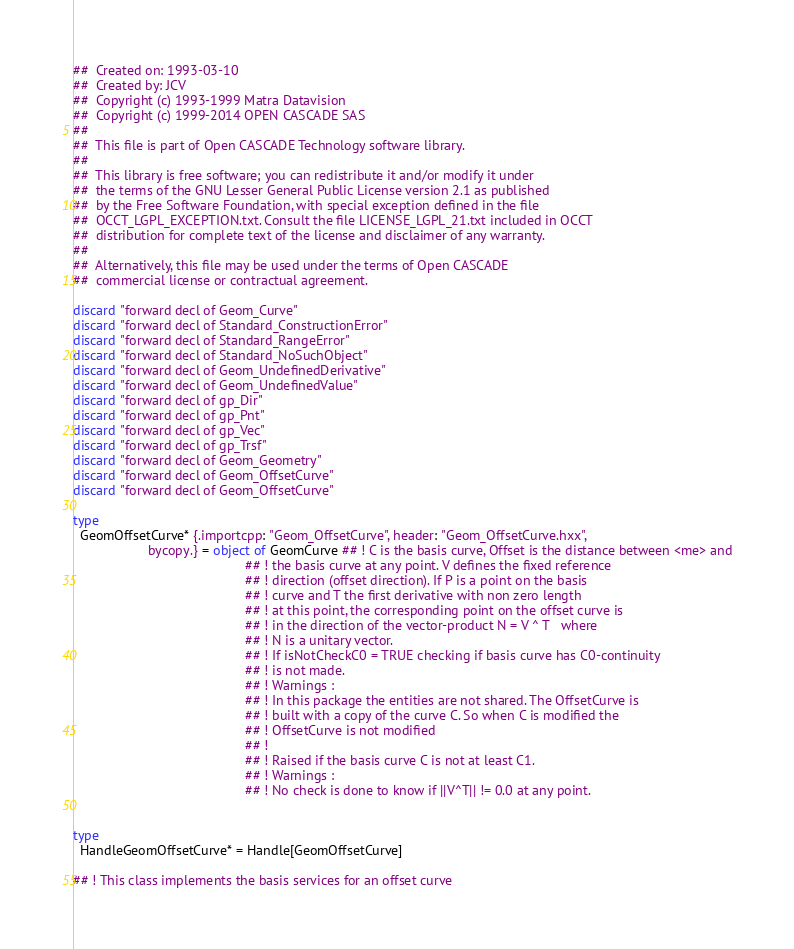<code> <loc_0><loc_0><loc_500><loc_500><_Nim_>##  Created on: 1993-03-10
##  Created by: JCV
##  Copyright (c) 1993-1999 Matra Datavision
##  Copyright (c) 1999-2014 OPEN CASCADE SAS
##
##  This file is part of Open CASCADE Technology software library.
##
##  This library is free software; you can redistribute it and/or modify it under
##  the terms of the GNU Lesser General Public License version 2.1 as published
##  by the Free Software Foundation, with special exception defined in the file
##  OCCT_LGPL_EXCEPTION.txt. Consult the file LICENSE_LGPL_21.txt included in OCCT
##  distribution for complete text of the license and disclaimer of any warranty.
##
##  Alternatively, this file may be used under the terms of Open CASCADE
##  commercial license or contractual agreement.

discard "forward decl of Geom_Curve"
discard "forward decl of Standard_ConstructionError"
discard "forward decl of Standard_RangeError"
discard "forward decl of Standard_NoSuchObject"
discard "forward decl of Geom_UndefinedDerivative"
discard "forward decl of Geom_UndefinedValue"
discard "forward decl of gp_Dir"
discard "forward decl of gp_Pnt"
discard "forward decl of gp_Vec"
discard "forward decl of gp_Trsf"
discard "forward decl of Geom_Geometry"
discard "forward decl of Geom_OffsetCurve"
discard "forward decl of Geom_OffsetCurve"

type
  GeomOffsetCurve* {.importcpp: "Geom_OffsetCurve", header: "Geom_OffsetCurve.hxx",
                    bycopy.} = object of GeomCurve ## ! C is the basis curve, Offset is the distance between <me> and
                                              ## ! the basis curve at any point. V defines the fixed reference
                                              ## ! direction (offset direction). If P is a point on the basis
                                              ## ! curve and T the first derivative with non zero length
                                              ## ! at this point, the corresponding point on the offset curve is
                                              ## ! in the direction of the vector-product N = V ^ T   where
                                              ## ! N is a unitary vector.
                                              ## ! If isNotCheckC0 = TRUE checking if basis curve has C0-continuity
                                              ## ! is not made.
                                              ## ! Warnings :
                                              ## ! In this package the entities are not shared. The OffsetCurve is
                                              ## ! built with a copy of the curve C. So when C is modified the
                                              ## ! OffsetCurve is not modified
                                              ## !
                                              ## ! Raised if the basis curve C is not at least C1.
                                              ## ! Warnings :
                                              ## ! No check is done to know if ||V^T|| != 0.0 at any point.


type
  HandleGeomOffsetCurve* = Handle[GeomOffsetCurve]

## ! This class implements the basis services for an offset curve</code> 